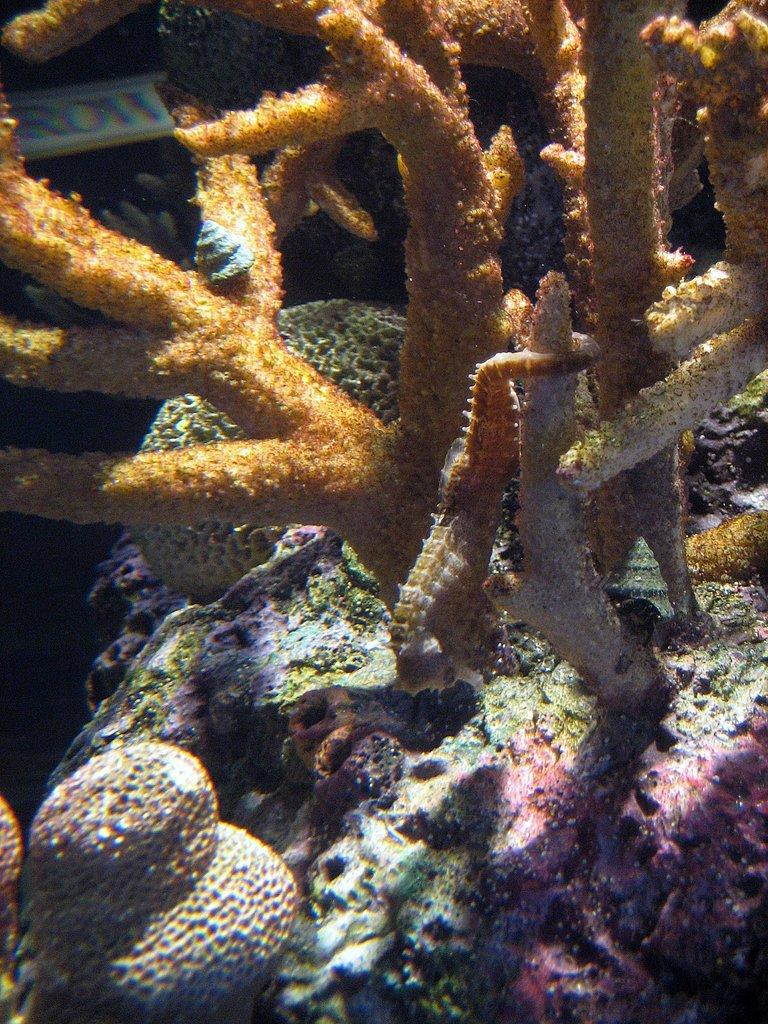What type of creatures are present in the image? There are underwater species in the image. Can you describe the appearance of these underwater species? The underwater species have different colors and different shapes. What type of toothbrush can be seen in the image? There is no toothbrush present in the image; it features underwater species. How many scales are visible on the underwater species in the image? The image does not show any scales on the underwater species, as it only provides information about their colors and shapes. 